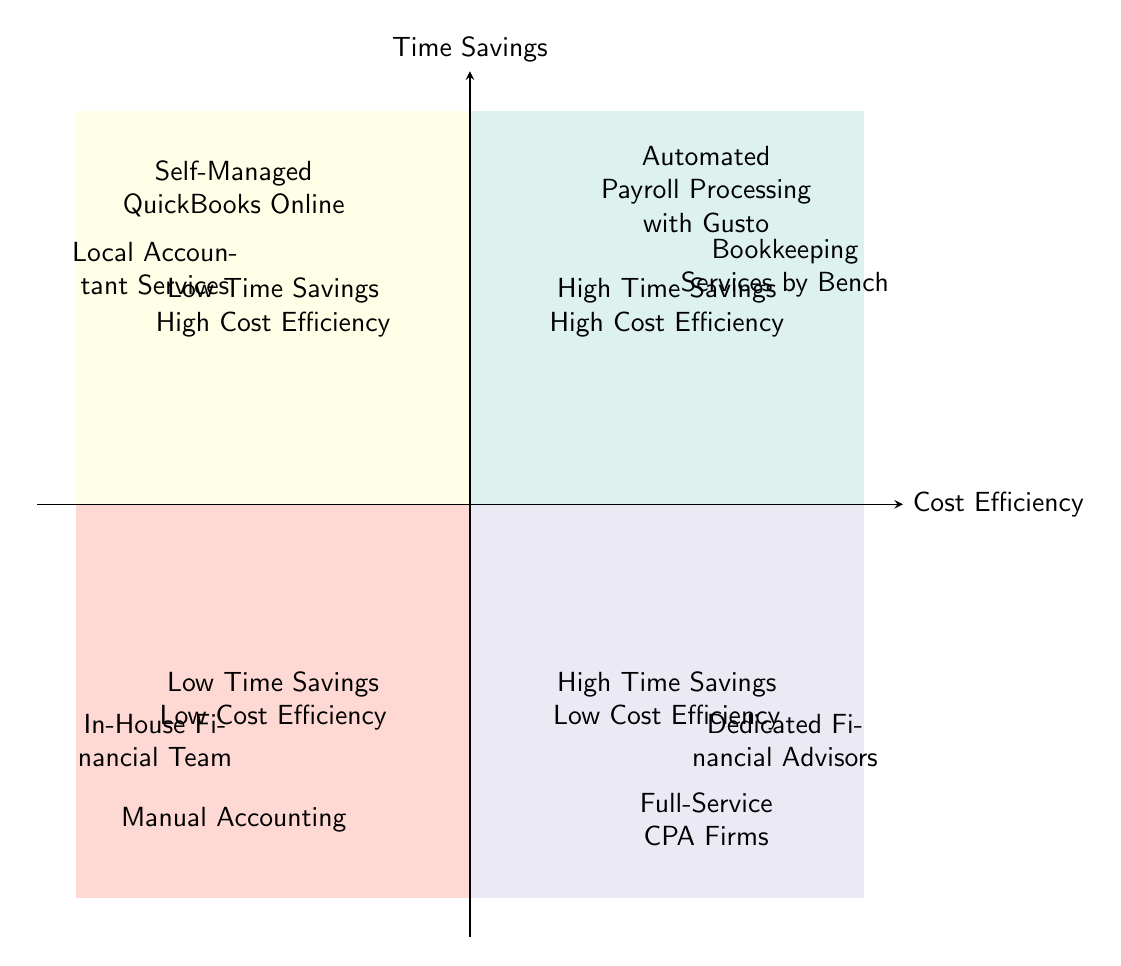What services are in the High Time Savings and High Cost Efficiency quadrant? The quadrant labeled "High Time Savings High Cost Efficiency" contains the services "Automated Payroll Processing with Gusto" and "Bookkeeping Services by Bench."
Answer: Automated Payroll Processing with Gusto, Bookkeeping Services by Bench Which quadrant contains "Manual Accounting"? "Manual Accounting" is located in the quadrant labeled "Low Time Savings Low Cost Efficiency." This can be determined by finding its position in the diagram's quadrants.
Answer: Low Time Savings Low Cost Efficiency How many services are positioned in the High Time Savings and Low Cost Efficiency quadrant? The quadrant "High Time Savings Low Cost Efficiency" includes two services: "Full-Service CPA Firms" and "Dedicated Financial Advisors." Thus, the total count is two.
Answer: 2 What is the relationship between Self-Managed QuickBooks Online and Local Accountant Services? Both services are positioned in the quadrant labeled "Low Time Savings High Cost Efficiency," indicating they have similar cost efficiency characteristics despite differing time savings.
Answer: Same quadrant Which quadrant has the least cost efficiency overall? The quadrant labeled "Low Time Savings Low Cost Efficiency" contains services that are the least cost-efficient according to the diagram. This quadrant includes "Manual Accounting" and "In-House Financial Team."
Answer: Low Time Savings Low Cost Efficiency How many services fall into the High Time Savings quadrant? The quadrants "High Time Savings High Cost Efficiency" and "High Time Savings Low Cost Efficiency" combined contain four services: "Automated Payroll Processing with Gusto," "Bookkeeping Services by Bench," "Full-Service CPA Firms," and "Dedicated Financial Advisors."
Answer: 4 What color represents the Low Time Savings and High Cost Efficiency quadrant? The quadrant for "Low Time Savings High Cost Efficiency" is shaded in a light yellow color, which is represented in the diagram.
Answer: Yellow Which service is the most cost-efficient among the offerings in the diagram? The diagram suggests that “Automated Payroll Processing with Gusto” and “Bookkeeping Services by Bench” are in the most cost-efficient quadrant, which is "High Time Savings High Cost Efficiency," indicating they offer the highest cost efficiency overall.
Answer: Automated Payroll Processing with Gusto, Bookkeeping Services by Bench 